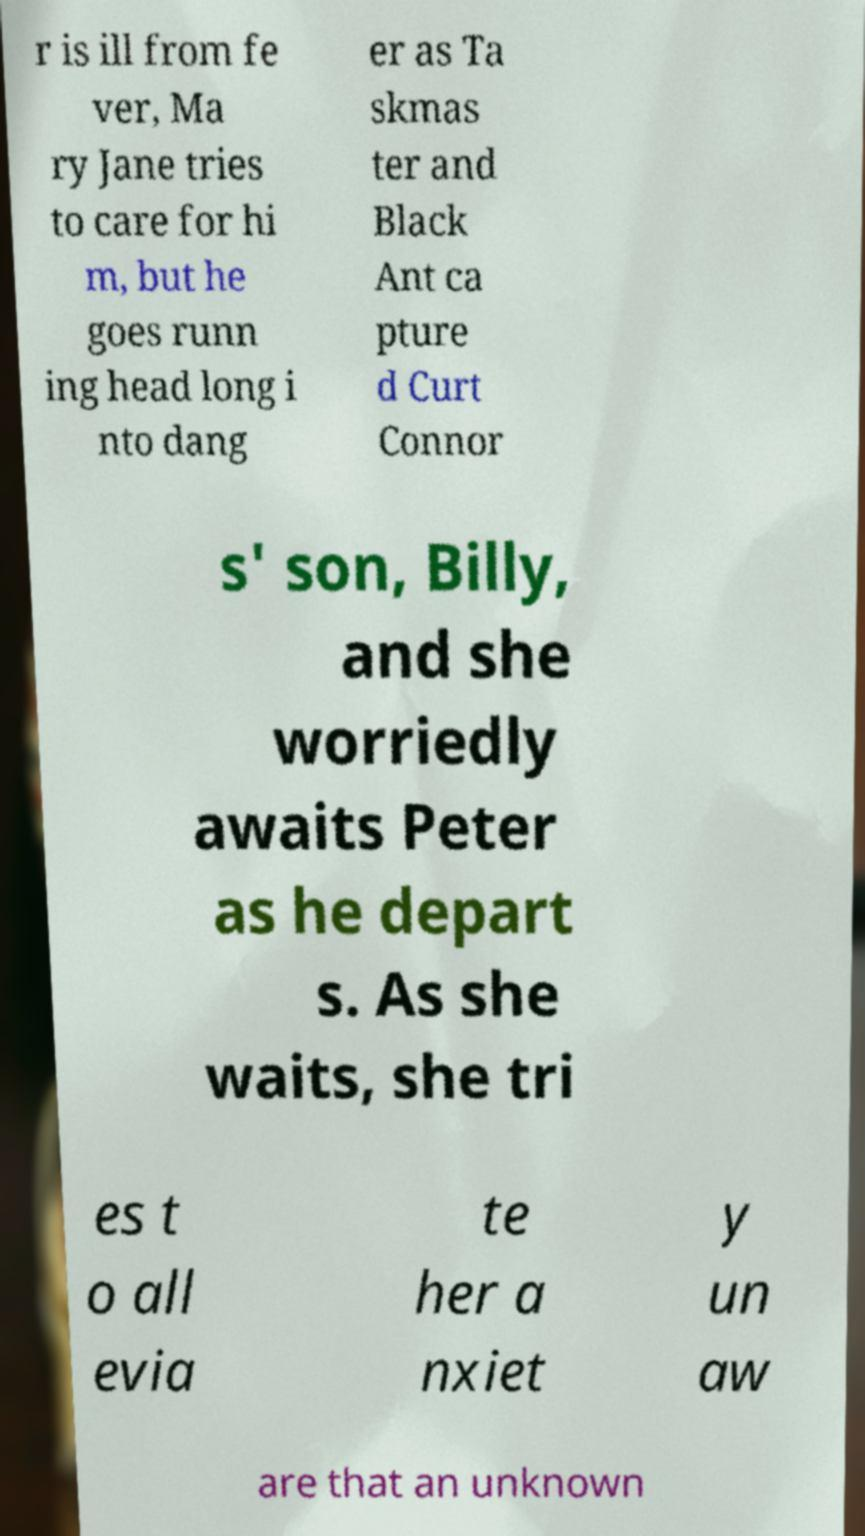Can you accurately transcribe the text from the provided image for me? r is ill from fe ver, Ma ry Jane tries to care for hi m, but he goes runn ing head long i nto dang er as Ta skmas ter and Black Ant ca pture d Curt Connor s' son, Billy, and she worriedly awaits Peter as he depart s. As she waits, she tri es t o all evia te her a nxiet y un aw are that an unknown 